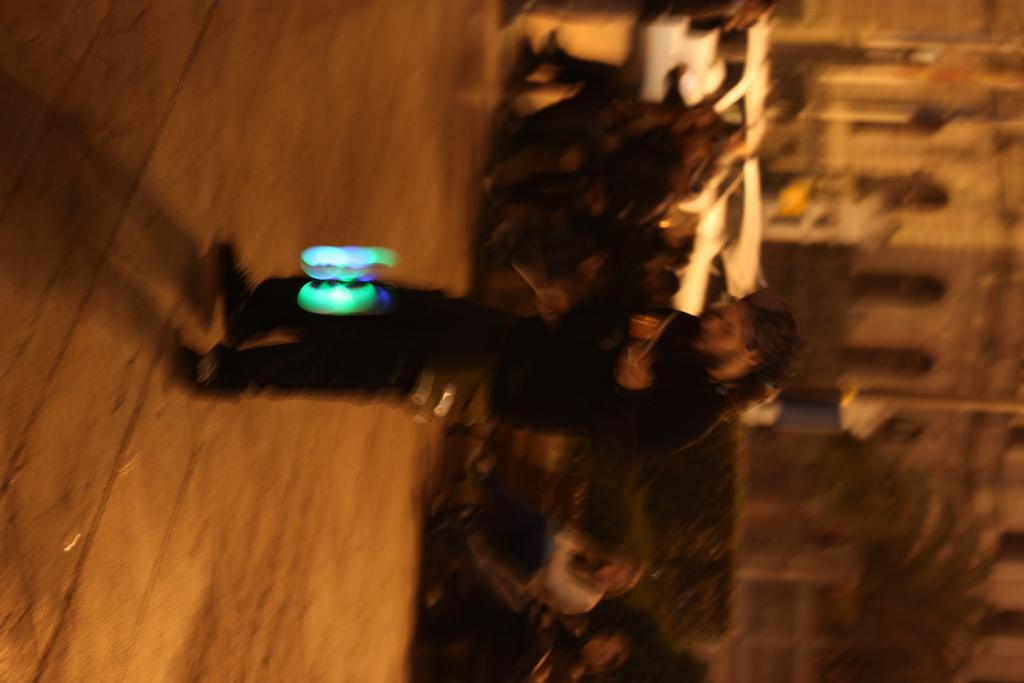What is the main subject of the image? There is a person standing on the road in the image. What can be seen in front of the person? There is an object or scene in colorful in front of the person. Can you describe the background of the image? The background of the image is blurred. What type of letters can be seen in the image? There are no letters present in the image. Can you tell me how many goats are visible in the image? There are no goats present in the image. 